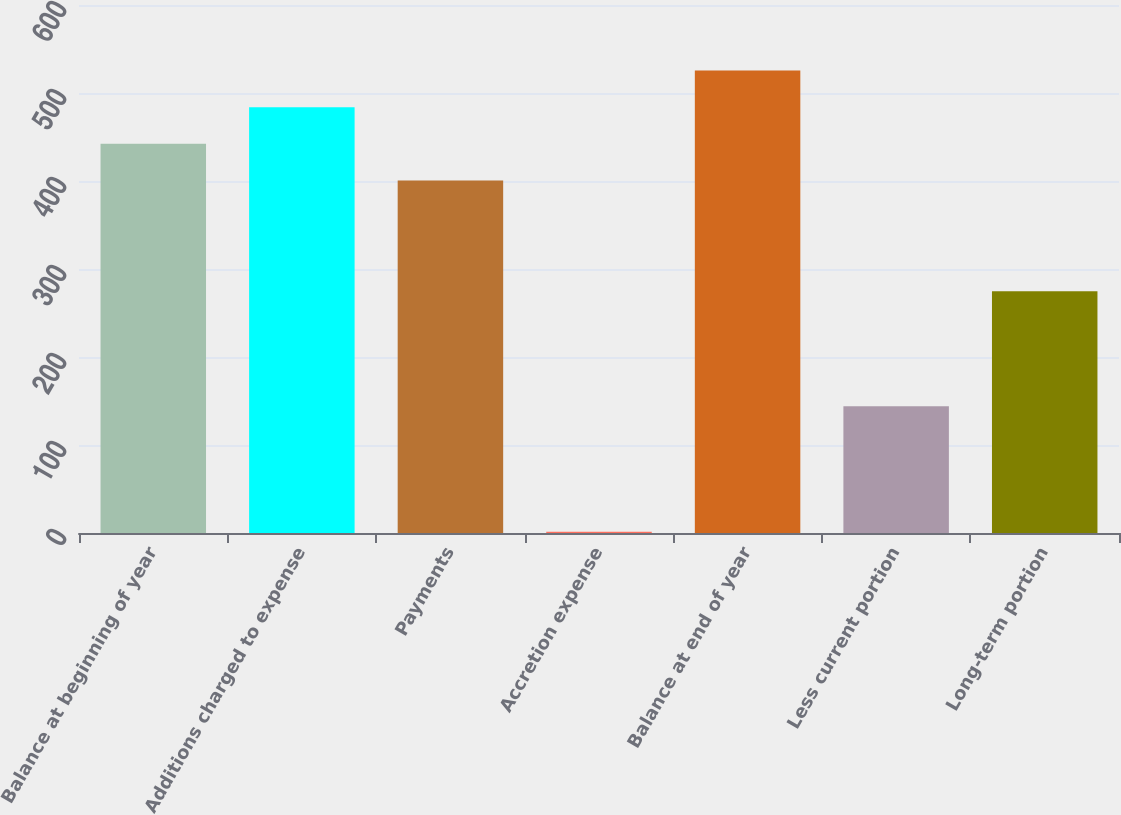Convert chart. <chart><loc_0><loc_0><loc_500><loc_500><bar_chart><fcel>Balance at beginning of year<fcel>Additions charged to expense<fcel>Payments<fcel>Accretion expense<fcel>Balance at end of year<fcel>Less current portion<fcel>Long-term portion<nl><fcel>442.2<fcel>483.9<fcel>400.5<fcel>1.5<fcel>525.6<fcel>143.9<fcel>274.6<nl></chart> 